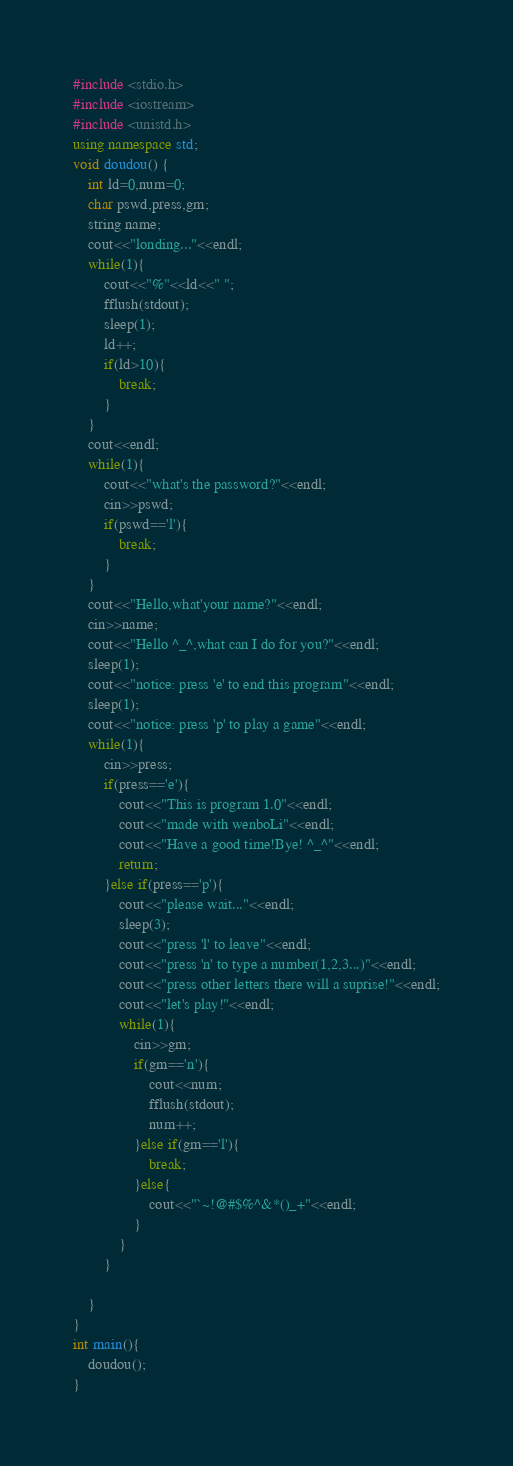Convert code to text. <code><loc_0><loc_0><loc_500><loc_500><_C++_>#include <stdio.h>
#include <iostream>
#include <unistd.h>
using namespace std;
void doudou() {
    int ld=0,num=0;
    char pswd,press,gm;
    string name;
    cout<<"londing..."<<endl;
    while(1){
        cout<<"%"<<ld<<" ";
        fflush(stdout);
        sleep(1);
        ld++;
        if(ld>10){
            break;
        }
    }
    cout<<endl;
    while(1){
        cout<<"what's the password?"<<endl;
        cin>>pswd;
        if(pswd=='l'){
            break;
        }
    }
    cout<<"Hello,what'your name?"<<endl;
    cin>>name;
    cout<<"Hello ^_^,what can I do for you?"<<endl;
    sleep(1);
    cout<<"notice: press 'e' to end this program"<<endl;
    sleep(1);
    cout<<"notice: press 'p' to play a game"<<endl;
    while(1){
        cin>>press;
        if(press=='e'){
            cout<<"This is program 1.0"<<endl;
            cout<<"made with wenboLi"<<endl;
            cout<<"Have a good time!Bye! ^_^"<<endl;
            return;
        }else if(press=='p'){
            cout<<"please wait..."<<endl;
            sleep(3);
            cout<<"press 'l' to leave"<<endl;
            cout<<"press 'n' to type a number(1,2,3...)"<<endl;
            cout<<"press other letters there will a suprise!"<<endl;
            cout<<"let's play!"<<endl;
            while(1){
                cin>>gm;
                if(gm=='n'){
                    cout<<num;
                    fflush(stdout);
                    num++;
                }else if(gm=='l'){
                    break;
                }else{
                    cout<<"`~!@#$%^&*()_+"<<endl;
                }
            }
        }
        
    }
}
int main(){
    doudou();
}
</code> 